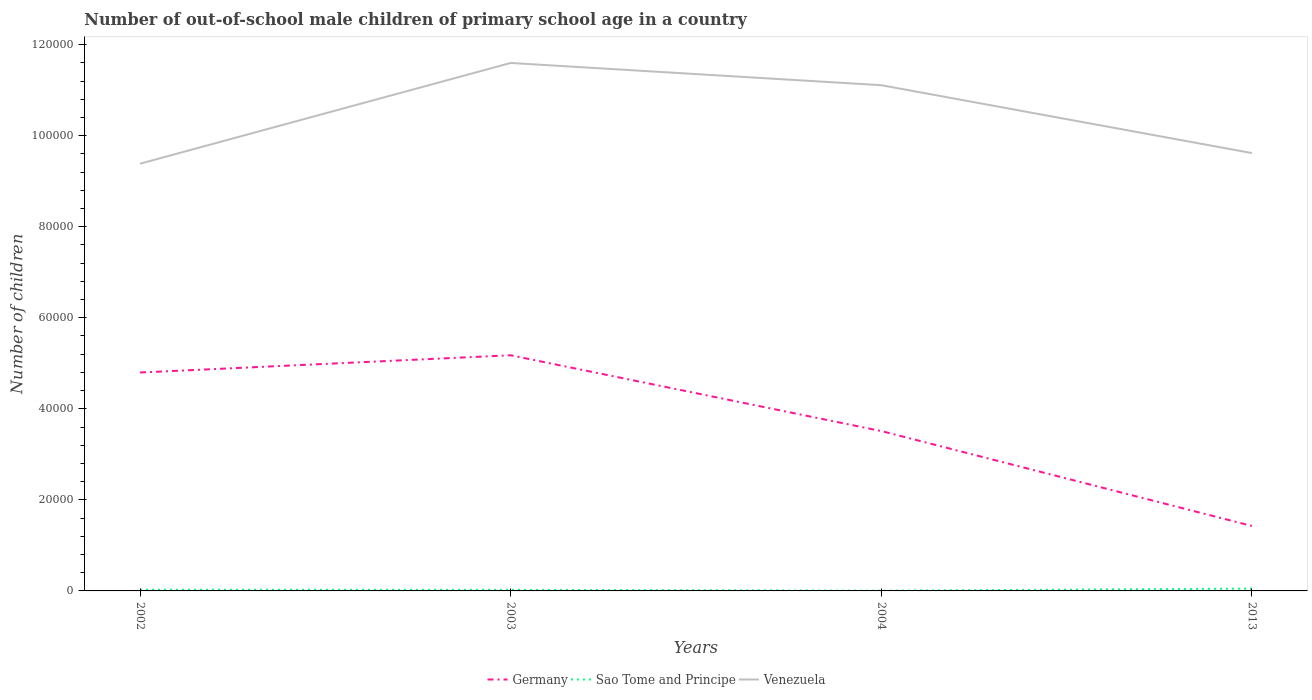How many different coloured lines are there?
Give a very brief answer. 3. Does the line corresponding to Venezuela intersect with the line corresponding to Sao Tome and Principe?
Your response must be concise. No. Across all years, what is the maximum number of out-of-school male children in Sao Tome and Principe?
Provide a short and direct response. 51. What is the total number of out-of-school male children in Venezuela in the graph?
Your response must be concise. 4886. What is the difference between the highest and the second highest number of out-of-school male children in Sao Tome and Principe?
Your answer should be compact. 462. What is the difference between the highest and the lowest number of out-of-school male children in Germany?
Provide a short and direct response. 2. Is the number of out-of-school male children in Venezuela strictly greater than the number of out-of-school male children in Sao Tome and Principe over the years?
Ensure brevity in your answer.  No. How many lines are there?
Your answer should be compact. 3. What is the difference between two consecutive major ticks on the Y-axis?
Make the answer very short. 2.00e+04. Does the graph contain any zero values?
Give a very brief answer. No. Where does the legend appear in the graph?
Make the answer very short. Bottom center. How many legend labels are there?
Keep it short and to the point. 3. How are the legend labels stacked?
Ensure brevity in your answer.  Horizontal. What is the title of the graph?
Make the answer very short. Number of out-of-school male children of primary school age in a country. What is the label or title of the Y-axis?
Your answer should be compact. Number of children. What is the Number of children in Germany in 2002?
Your response must be concise. 4.80e+04. What is the Number of children in Sao Tome and Principe in 2002?
Ensure brevity in your answer.  274. What is the Number of children of Venezuela in 2002?
Ensure brevity in your answer.  9.38e+04. What is the Number of children of Germany in 2003?
Make the answer very short. 5.18e+04. What is the Number of children of Sao Tome and Principe in 2003?
Make the answer very short. 248. What is the Number of children in Venezuela in 2003?
Your answer should be very brief. 1.16e+05. What is the Number of children of Germany in 2004?
Offer a very short reply. 3.51e+04. What is the Number of children of Venezuela in 2004?
Your answer should be very brief. 1.11e+05. What is the Number of children in Germany in 2013?
Make the answer very short. 1.43e+04. What is the Number of children in Sao Tome and Principe in 2013?
Provide a succinct answer. 513. What is the Number of children in Venezuela in 2013?
Provide a short and direct response. 9.62e+04. Across all years, what is the maximum Number of children of Germany?
Your response must be concise. 5.18e+04. Across all years, what is the maximum Number of children of Sao Tome and Principe?
Offer a terse response. 513. Across all years, what is the maximum Number of children in Venezuela?
Provide a succinct answer. 1.16e+05. Across all years, what is the minimum Number of children of Germany?
Provide a succinct answer. 1.43e+04. Across all years, what is the minimum Number of children of Venezuela?
Provide a succinct answer. 9.38e+04. What is the total Number of children of Germany in the graph?
Make the answer very short. 1.49e+05. What is the total Number of children of Sao Tome and Principe in the graph?
Provide a succinct answer. 1086. What is the total Number of children in Venezuela in the graph?
Your answer should be very brief. 4.17e+05. What is the difference between the Number of children of Germany in 2002 and that in 2003?
Provide a succinct answer. -3790. What is the difference between the Number of children in Sao Tome and Principe in 2002 and that in 2003?
Your response must be concise. 26. What is the difference between the Number of children in Venezuela in 2002 and that in 2003?
Offer a very short reply. -2.21e+04. What is the difference between the Number of children of Germany in 2002 and that in 2004?
Your answer should be compact. 1.29e+04. What is the difference between the Number of children in Sao Tome and Principe in 2002 and that in 2004?
Make the answer very short. 223. What is the difference between the Number of children of Venezuela in 2002 and that in 2004?
Provide a succinct answer. -1.72e+04. What is the difference between the Number of children in Germany in 2002 and that in 2013?
Keep it short and to the point. 3.37e+04. What is the difference between the Number of children of Sao Tome and Principe in 2002 and that in 2013?
Make the answer very short. -239. What is the difference between the Number of children of Venezuela in 2002 and that in 2013?
Your answer should be compact. -2333. What is the difference between the Number of children in Germany in 2003 and that in 2004?
Ensure brevity in your answer.  1.66e+04. What is the difference between the Number of children of Sao Tome and Principe in 2003 and that in 2004?
Keep it short and to the point. 197. What is the difference between the Number of children of Venezuela in 2003 and that in 2004?
Give a very brief answer. 4886. What is the difference between the Number of children in Germany in 2003 and that in 2013?
Offer a very short reply. 3.75e+04. What is the difference between the Number of children of Sao Tome and Principe in 2003 and that in 2013?
Your response must be concise. -265. What is the difference between the Number of children of Venezuela in 2003 and that in 2013?
Keep it short and to the point. 1.98e+04. What is the difference between the Number of children in Germany in 2004 and that in 2013?
Provide a short and direct response. 2.08e+04. What is the difference between the Number of children of Sao Tome and Principe in 2004 and that in 2013?
Provide a succinct answer. -462. What is the difference between the Number of children of Venezuela in 2004 and that in 2013?
Your answer should be very brief. 1.49e+04. What is the difference between the Number of children in Germany in 2002 and the Number of children in Sao Tome and Principe in 2003?
Your answer should be very brief. 4.77e+04. What is the difference between the Number of children of Germany in 2002 and the Number of children of Venezuela in 2003?
Your answer should be very brief. -6.80e+04. What is the difference between the Number of children in Sao Tome and Principe in 2002 and the Number of children in Venezuela in 2003?
Keep it short and to the point. -1.16e+05. What is the difference between the Number of children in Germany in 2002 and the Number of children in Sao Tome and Principe in 2004?
Provide a succinct answer. 4.79e+04. What is the difference between the Number of children in Germany in 2002 and the Number of children in Venezuela in 2004?
Your answer should be compact. -6.31e+04. What is the difference between the Number of children in Sao Tome and Principe in 2002 and the Number of children in Venezuela in 2004?
Ensure brevity in your answer.  -1.11e+05. What is the difference between the Number of children in Germany in 2002 and the Number of children in Sao Tome and Principe in 2013?
Offer a very short reply. 4.75e+04. What is the difference between the Number of children of Germany in 2002 and the Number of children of Venezuela in 2013?
Your answer should be compact. -4.82e+04. What is the difference between the Number of children of Sao Tome and Principe in 2002 and the Number of children of Venezuela in 2013?
Keep it short and to the point. -9.59e+04. What is the difference between the Number of children of Germany in 2003 and the Number of children of Sao Tome and Principe in 2004?
Make the answer very short. 5.17e+04. What is the difference between the Number of children of Germany in 2003 and the Number of children of Venezuela in 2004?
Offer a terse response. -5.93e+04. What is the difference between the Number of children in Sao Tome and Principe in 2003 and the Number of children in Venezuela in 2004?
Give a very brief answer. -1.11e+05. What is the difference between the Number of children of Germany in 2003 and the Number of children of Sao Tome and Principe in 2013?
Give a very brief answer. 5.13e+04. What is the difference between the Number of children in Germany in 2003 and the Number of children in Venezuela in 2013?
Ensure brevity in your answer.  -4.44e+04. What is the difference between the Number of children of Sao Tome and Principe in 2003 and the Number of children of Venezuela in 2013?
Ensure brevity in your answer.  -9.59e+04. What is the difference between the Number of children of Germany in 2004 and the Number of children of Sao Tome and Principe in 2013?
Offer a terse response. 3.46e+04. What is the difference between the Number of children of Germany in 2004 and the Number of children of Venezuela in 2013?
Provide a succinct answer. -6.11e+04. What is the difference between the Number of children in Sao Tome and Principe in 2004 and the Number of children in Venezuela in 2013?
Your answer should be very brief. -9.61e+04. What is the average Number of children in Germany per year?
Give a very brief answer. 3.73e+04. What is the average Number of children of Sao Tome and Principe per year?
Offer a very short reply. 271.5. What is the average Number of children in Venezuela per year?
Offer a terse response. 1.04e+05. In the year 2002, what is the difference between the Number of children of Germany and Number of children of Sao Tome and Principe?
Make the answer very short. 4.77e+04. In the year 2002, what is the difference between the Number of children of Germany and Number of children of Venezuela?
Offer a terse response. -4.59e+04. In the year 2002, what is the difference between the Number of children in Sao Tome and Principe and Number of children in Venezuela?
Give a very brief answer. -9.36e+04. In the year 2003, what is the difference between the Number of children in Germany and Number of children in Sao Tome and Principe?
Offer a very short reply. 5.15e+04. In the year 2003, what is the difference between the Number of children of Germany and Number of children of Venezuela?
Provide a succinct answer. -6.42e+04. In the year 2003, what is the difference between the Number of children of Sao Tome and Principe and Number of children of Venezuela?
Offer a very short reply. -1.16e+05. In the year 2004, what is the difference between the Number of children of Germany and Number of children of Sao Tome and Principe?
Your response must be concise. 3.51e+04. In the year 2004, what is the difference between the Number of children in Germany and Number of children in Venezuela?
Keep it short and to the point. -7.60e+04. In the year 2004, what is the difference between the Number of children in Sao Tome and Principe and Number of children in Venezuela?
Give a very brief answer. -1.11e+05. In the year 2013, what is the difference between the Number of children of Germany and Number of children of Sao Tome and Principe?
Your answer should be very brief. 1.38e+04. In the year 2013, what is the difference between the Number of children of Germany and Number of children of Venezuela?
Provide a short and direct response. -8.19e+04. In the year 2013, what is the difference between the Number of children in Sao Tome and Principe and Number of children in Venezuela?
Your response must be concise. -9.57e+04. What is the ratio of the Number of children of Germany in 2002 to that in 2003?
Give a very brief answer. 0.93. What is the ratio of the Number of children in Sao Tome and Principe in 2002 to that in 2003?
Offer a terse response. 1.1. What is the ratio of the Number of children in Venezuela in 2002 to that in 2003?
Ensure brevity in your answer.  0.81. What is the ratio of the Number of children of Germany in 2002 to that in 2004?
Make the answer very short. 1.37. What is the ratio of the Number of children of Sao Tome and Principe in 2002 to that in 2004?
Your response must be concise. 5.37. What is the ratio of the Number of children in Venezuela in 2002 to that in 2004?
Your answer should be very brief. 0.84. What is the ratio of the Number of children of Germany in 2002 to that in 2013?
Keep it short and to the point. 3.36. What is the ratio of the Number of children in Sao Tome and Principe in 2002 to that in 2013?
Provide a succinct answer. 0.53. What is the ratio of the Number of children of Venezuela in 2002 to that in 2013?
Provide a short and direct response. 0.98. What is the ratio of the Number of children of Germany in 2003 to that in 2004?
Provide a short and direct response. 1.47. What is the ratio of the Number of children of Sao Tome and Principe in 2003 to that in 2004?
Your answer should be compact. 4.86. What is the ratio of the Number of children in Venezuela in 2003 to that in 2004?
Give a very brief answer. 1.04. What is the ratio of the Number of children of Germany in 2003 to that in 2013?
Your answer should be compact. 3.63. What is the ratio of the Number of children in Sao Tome and Principe in 2003 to that in 2013?
Provide a short and direct response. 0.48. What is the ratio of the Number of children in Venezuela in 2003 to that in 2013?
Your response must be concise. 1.21. What is the ratio of the Number of children in Germany in 2004 to that in 2013?
Keep it short and to the point. 2.46. What is the ratio of the Number of children of Sao Tome and Principe in 2004 to that in 2013?
Offer a very short reply. 0.1. What is the ratio of the Number of children of Venezuela in 2004 to that in 2013?
Give a very brief answer. 1.16. What is the difference between the highest and the second highest Number of children of Germany?
Ensure brevity in your answer.  3790. What is the difference between the highest and the second highest Number of children in Sao Tome and Principe?
Provide a succinct answer. 239. What is the difference between the highest and the second highest Number of children of Venezuela?
Give a very brief answer. 4886. What is the difference between the highest and the lowest Number of children in Germany?
Provide a succinct answer. 3.75e+04. What is the difference between the highest and the lowest Number of children in Sao Tome and Principe?
Your answer should be compact. 462. What is the difference between the highest and the lowest Number of children of Venezuela?
Make the answer very short. 2.21e+04. 